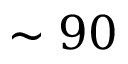<formula> <loc_0><loc_0><loc_500><loc_500>\sim 9 0</formula> 